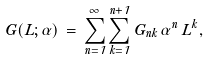Convert formula to latex. <formula><loc_0><loc_0><loc_500><loc_500>G ( L ; \alpha ) \, = \, \sum _ { n = 1 } ^ { \infty } \sum _ { k = 1 } ^ { n + 1 } G _ { n k } \, \alpha ^ { n } \, L ^ { k } ,</formula> 